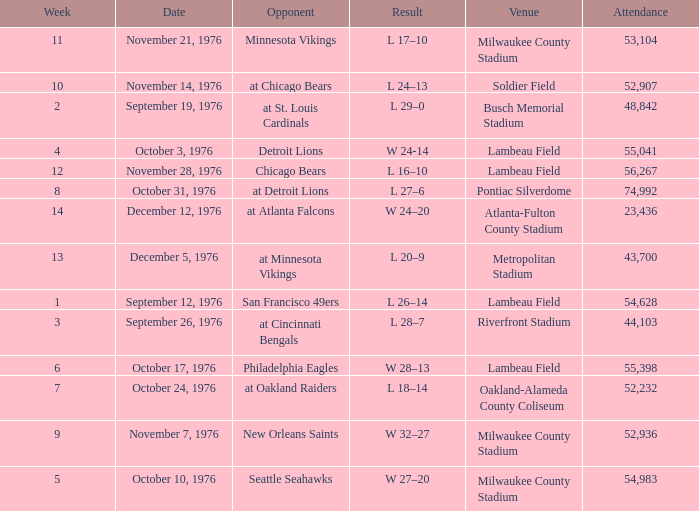How many people attended the game on September 19, 1976? 1.0. 